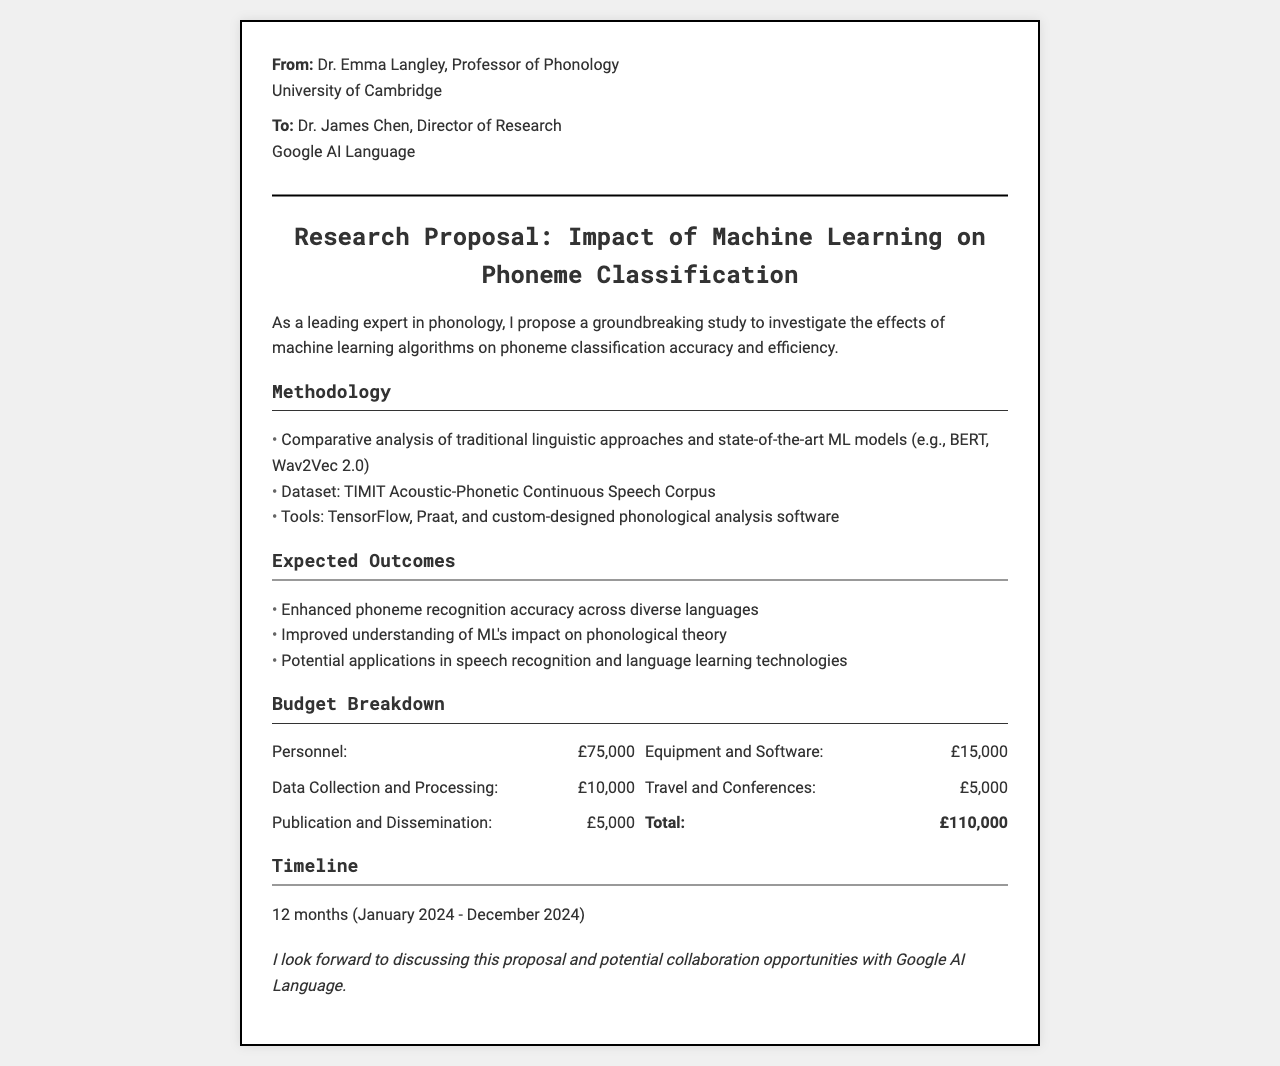What is the total budget for the research proposal? The total budget is the sum of all the budget items listed in the document, which comes to £75,000 + £15,000 + £10,000 + £5,000 + £5,000 = £110,000.
Answer: £110,000 Who is the recipient of the fax? The recipient of the fax is specified in the document, identifying the person to whom the proposal is sent.
Answer: Dr. James Chen What tools will be used in the research? The document lists specific tools that will be employed in the research methodology, including software for analysis.
Answer: TensorFlow, Praat, and custom-designed phonological analysis software What is the primary objective of the research? The main goal of the research is outlined in the introduction section, focusing on phoneme classification.
Answer: Investigate the effects of machine learning algorithms on phoneme classification accuracy and efficiency What is the expected timeline for the study? The proposal provides a specified duration for the research project, indicating the period it will span.
Answer: 12 months (January 2024 - December 2024) How much is allocated for travel and conferences? The budget details specify how much funding is designated for travel and associated conferences.
Answer: £5,000 What dataset will be utilized for the study? The document mentions a specific dataset that will serve as the foundation for the research analysis.
Answer: TIMIT Acoustic-Phonetic Continuous Speech Corpus What are the expected outcomes of the research? The proposal lists anticipated results that will arise from conducting the study, summarizing its benefits.
Answer: Enhanced phoneme recognition accuracy across diverse languages 